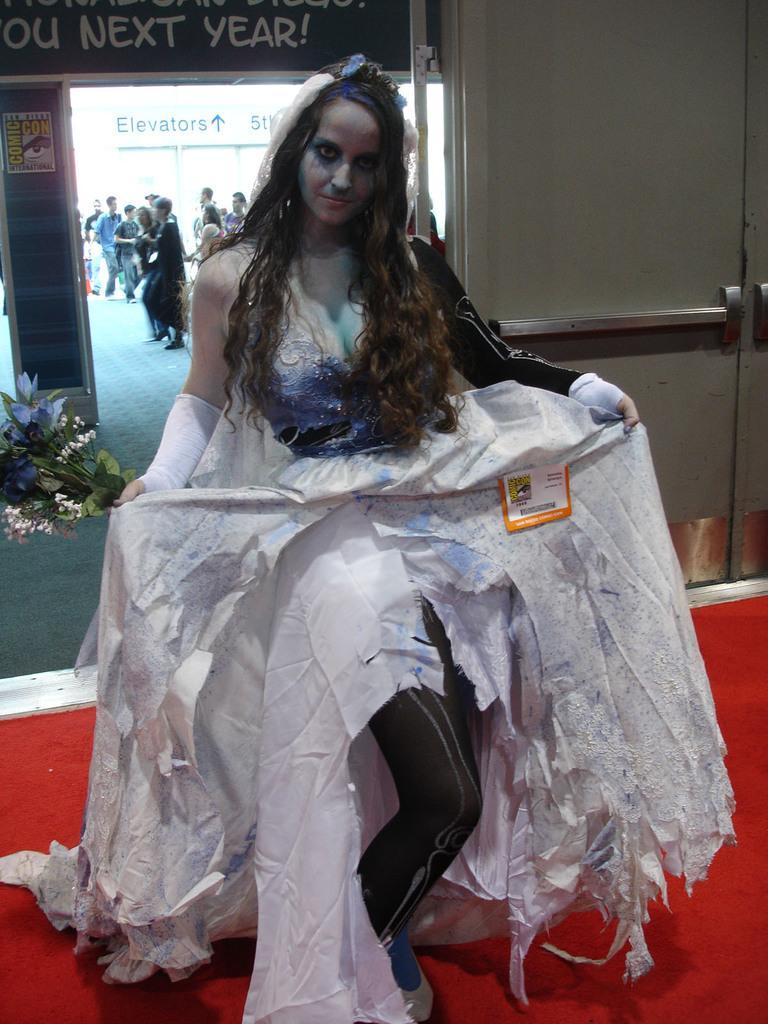Can you describe this image briefly? In this picture there is a woman standing and wearing Halloween makeup and white dress and holding flowers with stems and leaves. In the background of the image we can see people, boards, poster and door. 